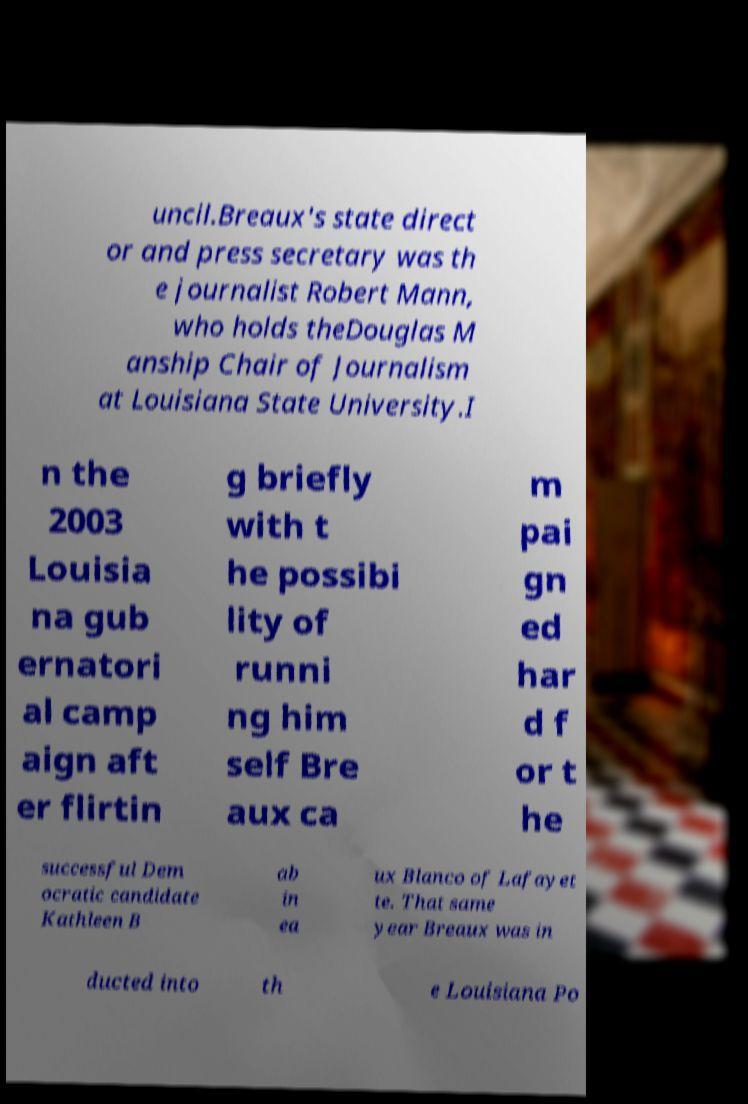What messages or text are displayed in this image? I need them in a readable, typed format. uncil.Breaux's state direct or and press secretary was th e journalist Robert Mann, who holds theDouglas M anship Chair of Journalism at Louisiana State University.I n the 2003 Louisia na gub ernatori al camp aign aft er flirtin g briefly with t he possibi lity of runni ng him self Bre aux ca m pai gn ed har d f or t he successful Dem ocratic candidate Kathleen B ab in ea ux Blanco of Lafayet te. That same year Breaux was in ducted into th e Louisiana Po 